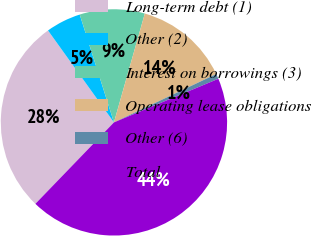Convert chart to OTSL. <chart><loc_0><loc_0><loc_500><loc_500><pie_chart><fcel>Long-term debt (1)<fcel>Other (2)<fcel>Interest on borrowings (3)<fcel>Operating lease obligations<fcel>Other (6)<fcel>Total<nl><fcel>27.88%<fcel>5.01%<fcel>9.29%<fcel>13.57%<fcel>0.73%<fcel>43.51%<nl></chart> 